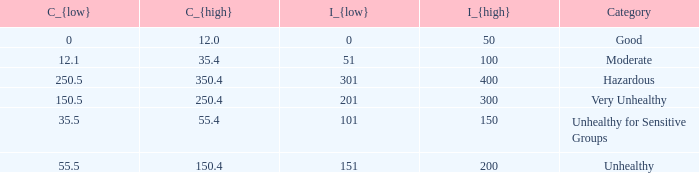In how many different categories is the value of C_{low} 35.5? 1.0. 